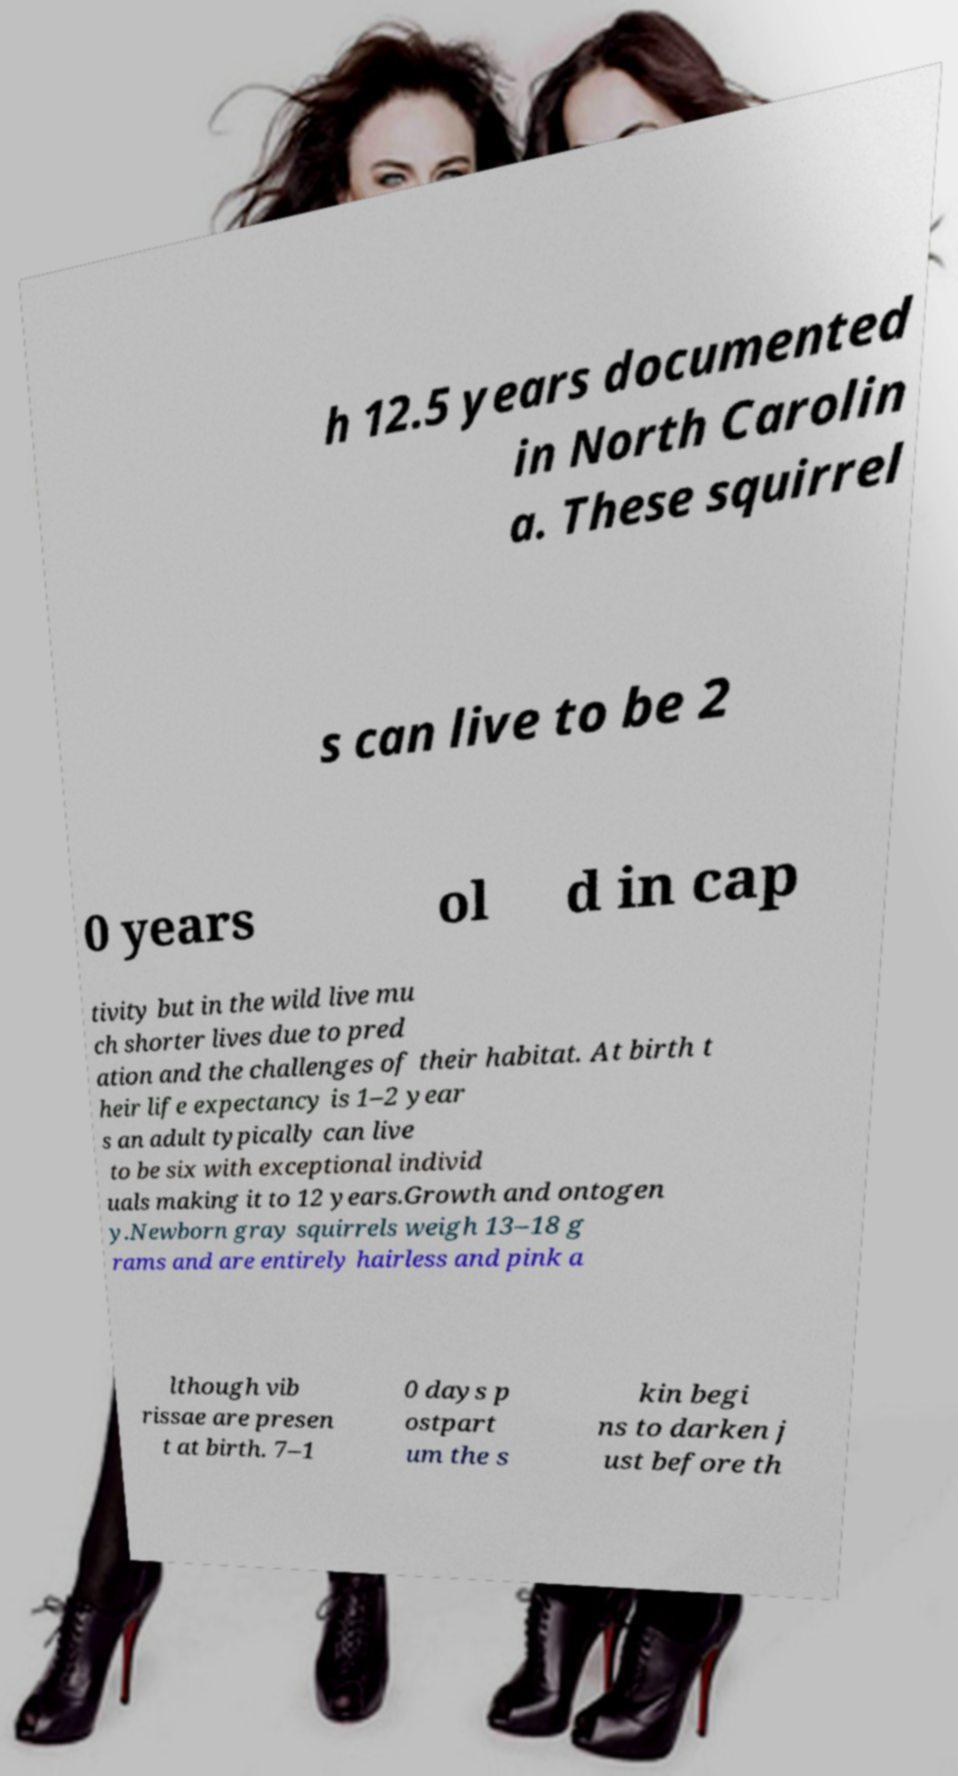For documentation purposes, I need the text within this image transcribed. Could you provide that? h 12.5 years documented in North Carolin a. These squirrel s can live to be 2 0 years ol d in cap tivity but in the wild live mu ch shorter lives due to pred ation and the challenges of their habitat. At birth t heir life expectancy is 1–2 year s an adult typically can live to be six with exceptional individ uals making it to 12 years.Growth and ontogen y.Newborn gray squirrels weigh 13–18 g rams and are entirely hairless and pink a lthough vib rissae are presen t at birth. 7–1 0 days p ostpart um the s kin begi ns to darken j ust before th 